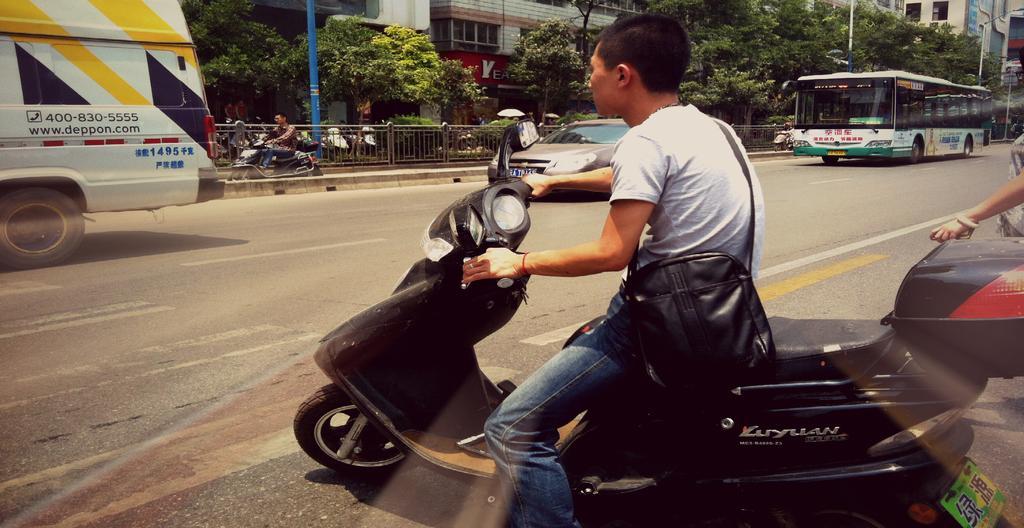Can you describe this image briefly? This picture consists of a road, on the road there are buses and car visible ,at the bottom a person riding on bi-cycle visible on road, on the right side I can see a person's hand which is holding a vehicle, in the middle there is a fence, trees, poles, buildings, a person riding on bi-cycle in front of fence visible. 